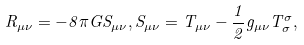<formula> <loc_0><loc_0><loc_500><loc_500>R _ { \mu \nu } = - 8 \pi G S _ { \mu \nu } , S _ { \mu \nu } = T _ { \mu \nu } - \frac { 1 } { 2 } g _ { \mu \nu } T ^ { \sigma } _ { \sigma } ,</formula> 